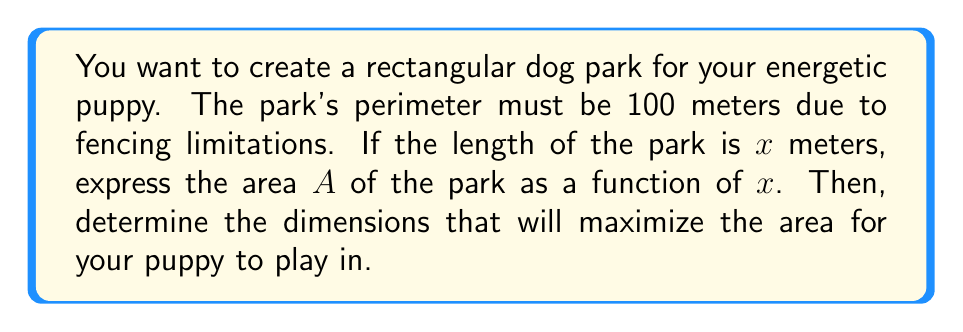Give your solution to this math problem. 1) Let the width of the park be $y$ meters. Since the perimeter is 100 meters:
   $$2x + 2y = 100$$

2) Solve for $y$:
   $$y = 50 - x$$

3) The area $A$ of the park is length times width:
   $$A = x(50-x) = 50x - x^2$$

4) To find the maximum area, we need to find the vertex of this quadratic function. The vertex occurs at the axis of symmetry, which is halfway between the roots.

5) We can find the axis of symmetry using the formula $x = -\frac{b}{2a}$ where $a$ and $b$ are the coefficients of the quadratic function $ax^2 + bx + c$:

   $$x = -\frac{50}{2(-1)} = 25$$

6) This means the optimal length is 25 meters. The corresponding width is:
   $$y = 50 - 25 = 25$$ meters

7) The maximum area is therefore:
   $$A = 25 * 25 = 625$$ square meters

[asy]
unitsize(4mm);
draw((0,0)--(25,0)--(25,25)--(0,25)--cycle);
label("25 m", (12.5,0), S);
label("25 m", (0,12.5), W);
label("Optimal Dog Park", (12.5,27), N);
[/asy]
Answer: 25 m × 25 m, 625 m² 